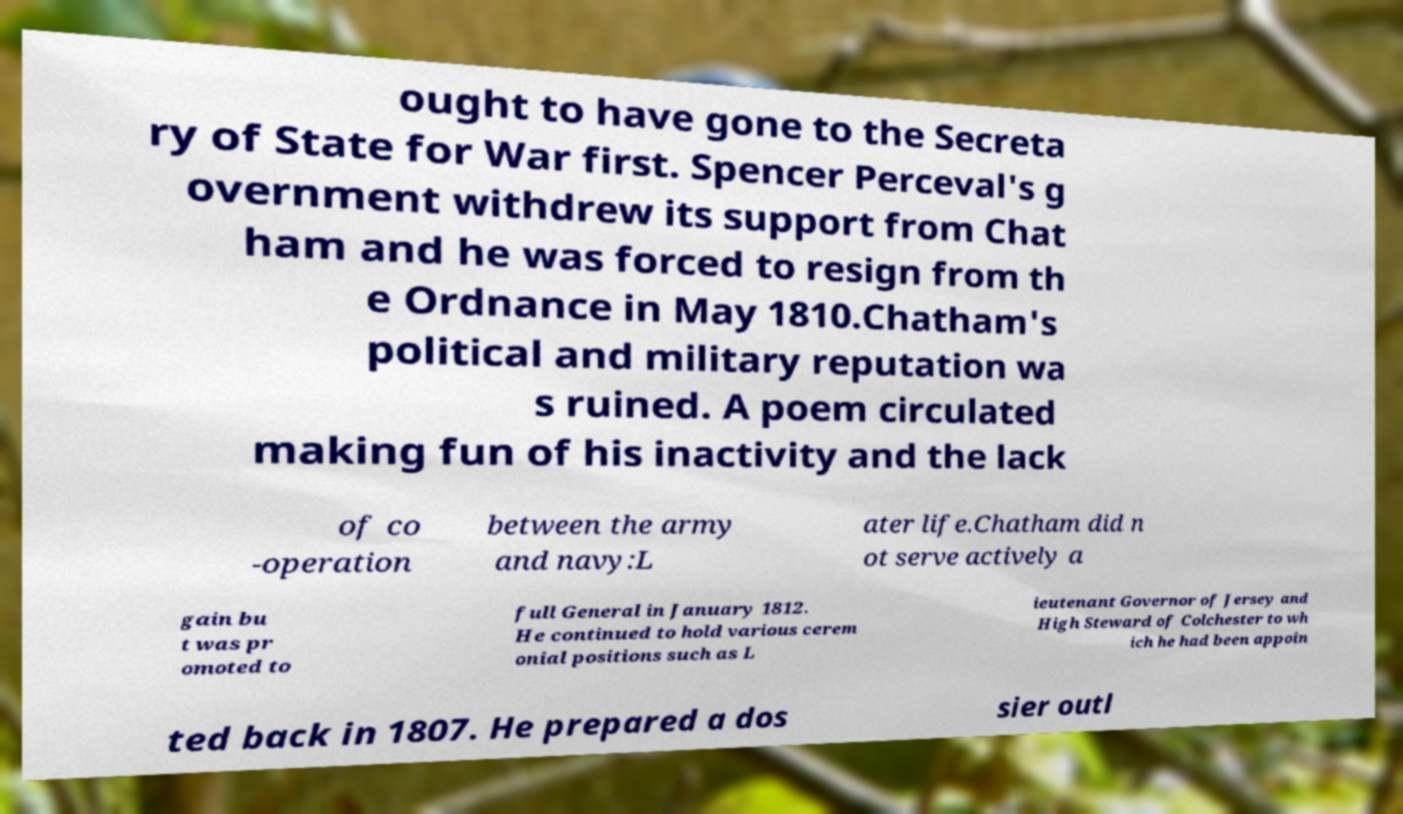I need the written content from this picture converted into text. Can you do that? ought to have gone to the Secreta ry of State for War first. Spencer Perceval's g overnment withdrew its support from Chat ham and he was forced to resign from th e Ordnance in May 1810.Chatham's political and military reputation wa s ruined. A poem circulated making fun of his inactivity and the lack of co -operation between the army and navy:L ater life.Chatham did n ot serve actively a gain bu t was pr omoted to full General in January 1812. He continued to hold various cerem onial positions such as L ieutenant Governor of Jersey and High Steward of Colchester to wh ich he had been appoin ted back in 1807. He prepared a dos sier outl 